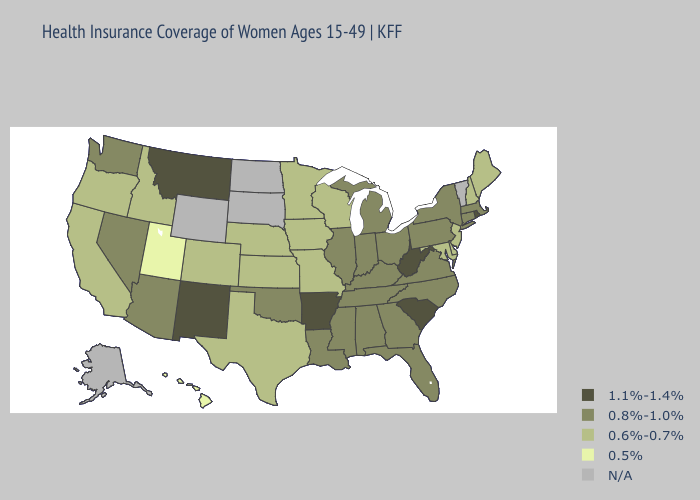What is the lowest value in states that border Tennessee?
Write a very short answer. 0.6%-0.7%. What is the lowest value in states that border Illinois?
Write a very short answer. 0.6%-0.7%. Does South Carolina have the lowest value in the South?
Keep it brief. No. What is the highest value in the South ?
Be succinct. 1.1%-1.4%. How many symbols are there in the legend?
Keep it brief. 5. Does New York have the highest value in the USA?
Give a very brief answer. No. Is the legend a continuous bar?
Be succinct. No. Name the states that have a value in the range 1.1%-1.4%?
Concise answer only. Arkansas, Montana, New Mexico, Rhode Island, South Carolina, West Virginia. What is the value of North Carolina?
Short answer required. 0.8%-1.0%. What is the highest value in states that border North Dakota?
Short answer required. 1.1%-1.4%. Which states have the lowest value in the USA?
Concise answer only. Hawaii, Utah. Which states have the highest value in the USA?
Quick response, please. Arkansas, Montana, New Mexico, Rhode Island, South Carolina, West Virginia. What is the value of Washington?
Concise answer only. 0.8%-1.0%. Which states have the lowest value in the MidWest?
Be succinct. Iowa, Kansas, Minnesota, Missouri, Nebraska, Wisconsin. Does the map have missing data?
Short answer required. Yes. 